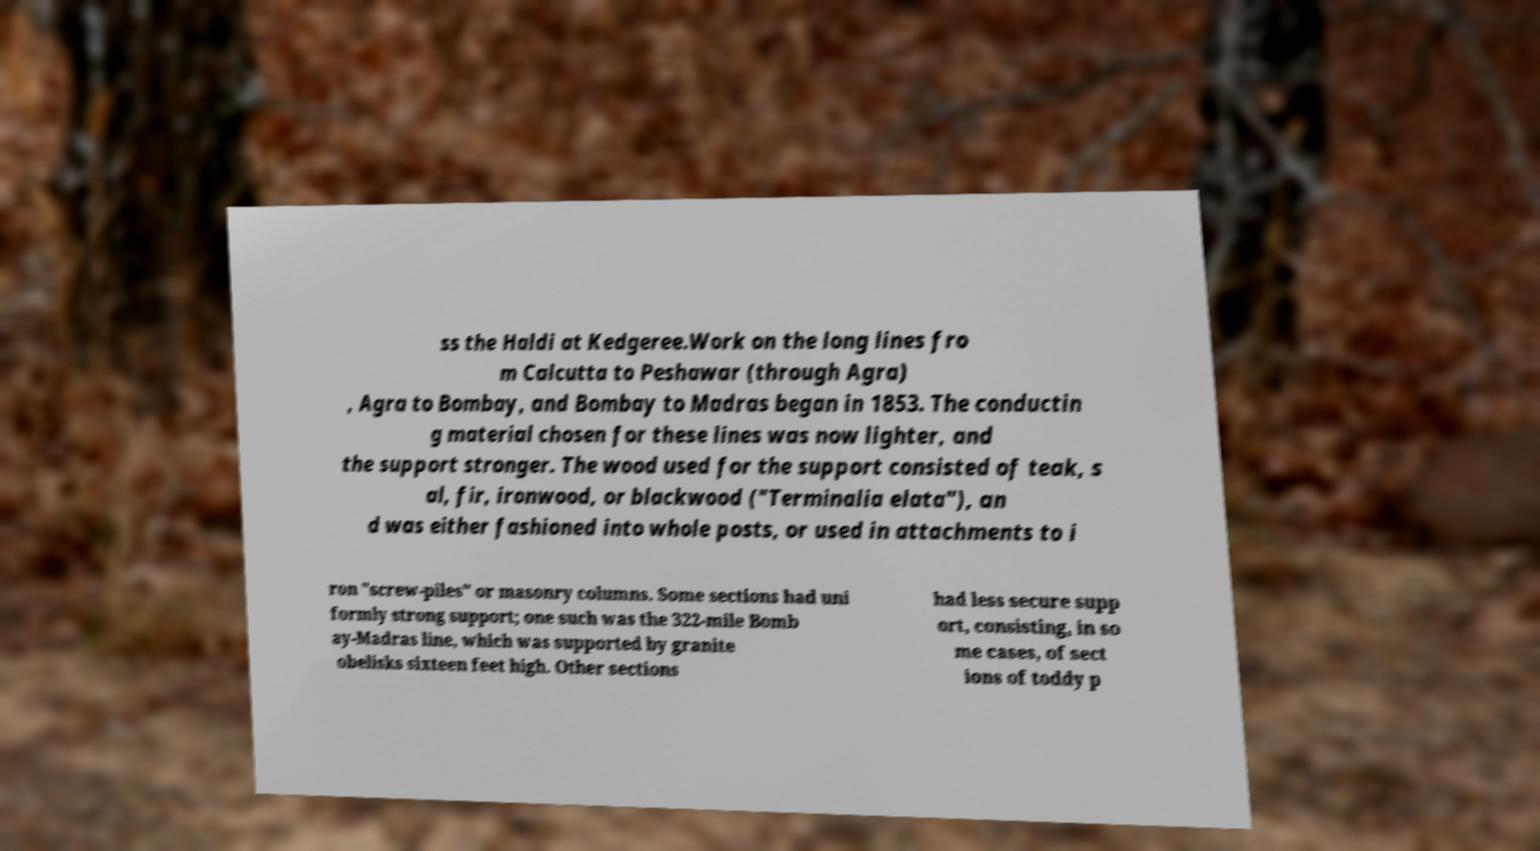Please read and relay the text visible in this image. What does it say? ss the Haldi at Kedgeree.Work on the long lines fro m Calcutta to Peshawar (through Agra) , Agra to Bombay, and Bombay to Madras began in 1853. The conductin g material chosen for these lines was now lighter, and the support stronger. The wood used for the support consisted of teak, s al, fir, ironwood, or blackwood ("Terminalia elata"), an d was either fashioned into whole posts, or used in attachments to i ron "screw-piles" or masonry columns. Some sections had uni formly strong support; one such was the 322-mile Bomb ay-Madras line, which was supported by granite obelisks sixteen feet high. Other sections had less secure supp ort, consisting, in so me cases, of sect ions of toddy p 